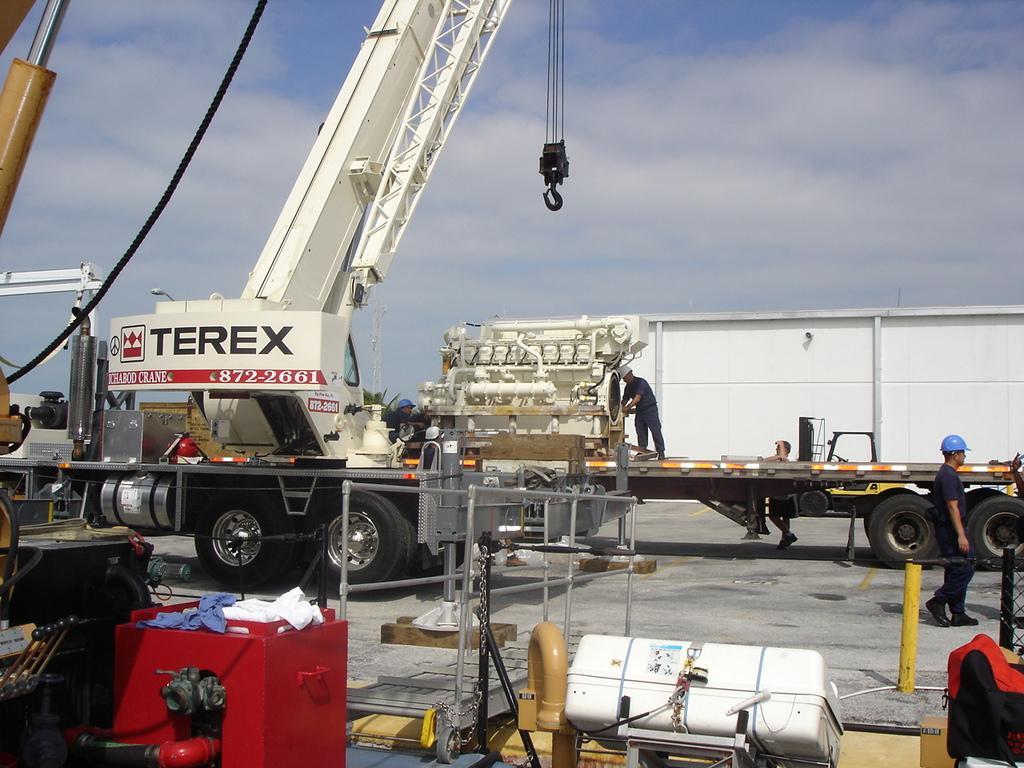Can you describe this image briefly? There are people and we can vehicles and rope. We can see red box, clothes, fence, rods, chain and objects. In the background we can see sky with clouds. 